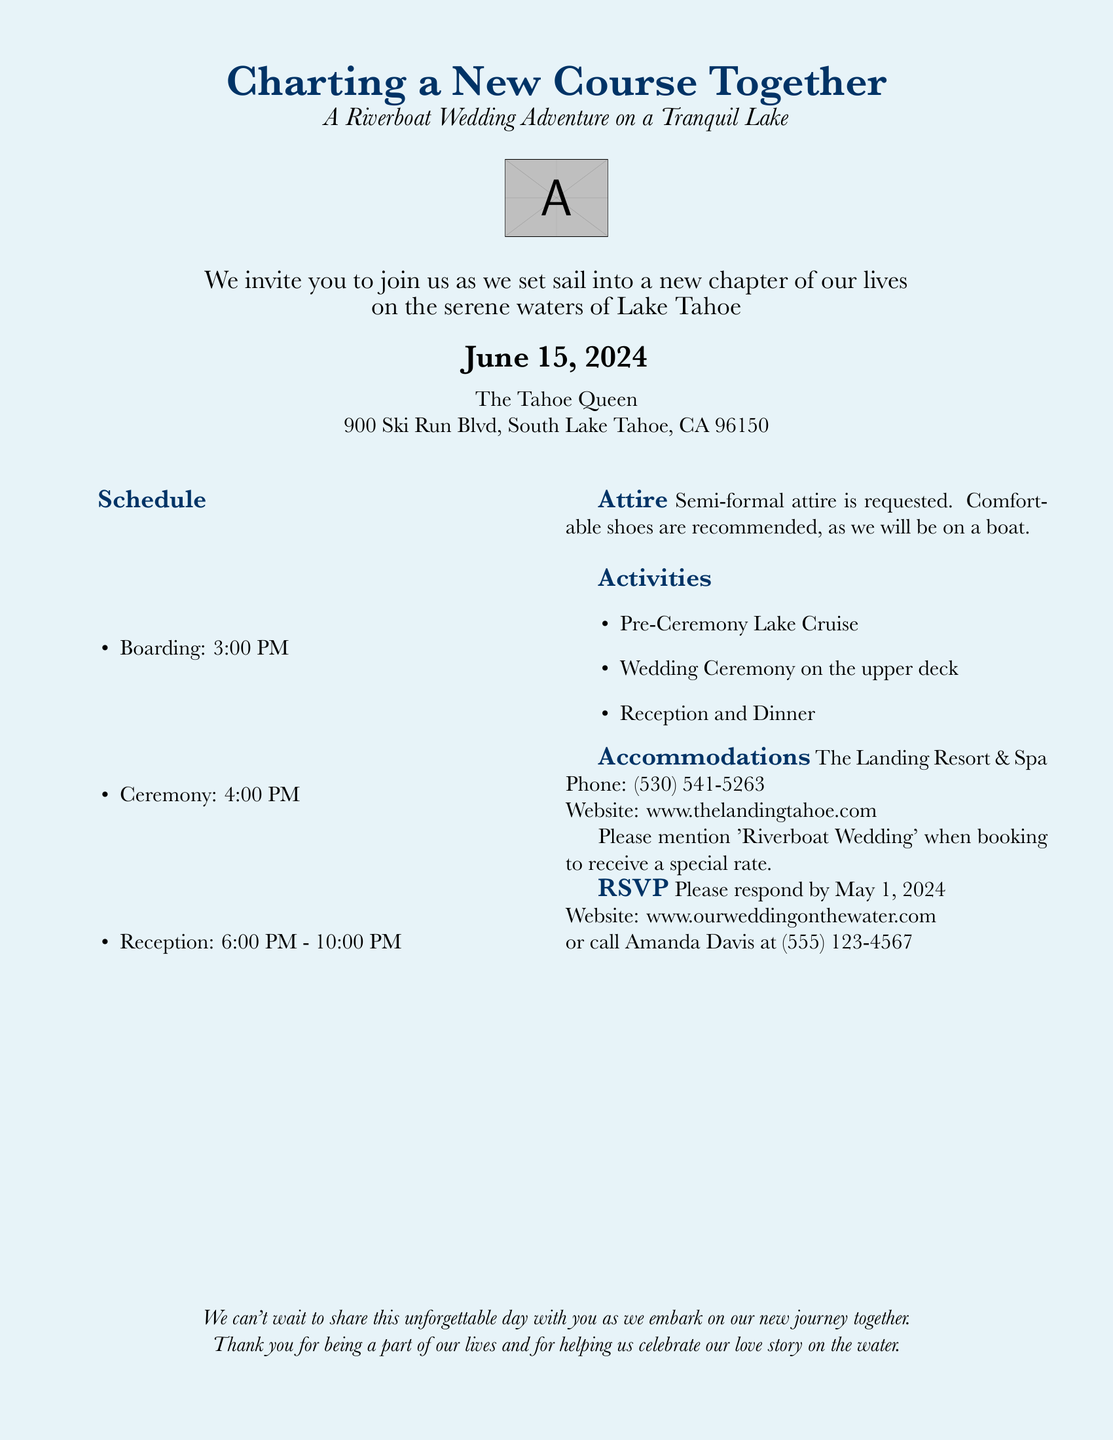What is the date of the wedding? The date of the wedding is explicitly stated in the document.
Answer: June 15, 2024 What time does the ceremony start? The ceremony time is provided in the schedule section of the document.
Answer: 4:00 PM What is the location of the wedding? The location is specified in the document under the venue details.
Answer: The Tahoe Queen What attire is requested for the event? The attire requested for the wedding is mentioned in the document.
Answer: Semi-formal attire When is the RSVP deadline? The RSVP deadline is clearly outlined in the invitation.
Answer: May 1, 2024 What activities are planned before the ceremony? The planned activities before the ceremony are listed in the document.
Answer: Pre-Ceremony Lake Cruise How long does the reception last? The reception duration is mentioned in the schedule provided.
Answer: 4 hours What is recommended for footwear? The document suggests a specific type of footwear based on the event location.
Answer: Comfortable shoes Where can guests find accommodation details? Accommodation details are specified in a dedicated section of the document.
Answer: The Landing Resort & Spa 